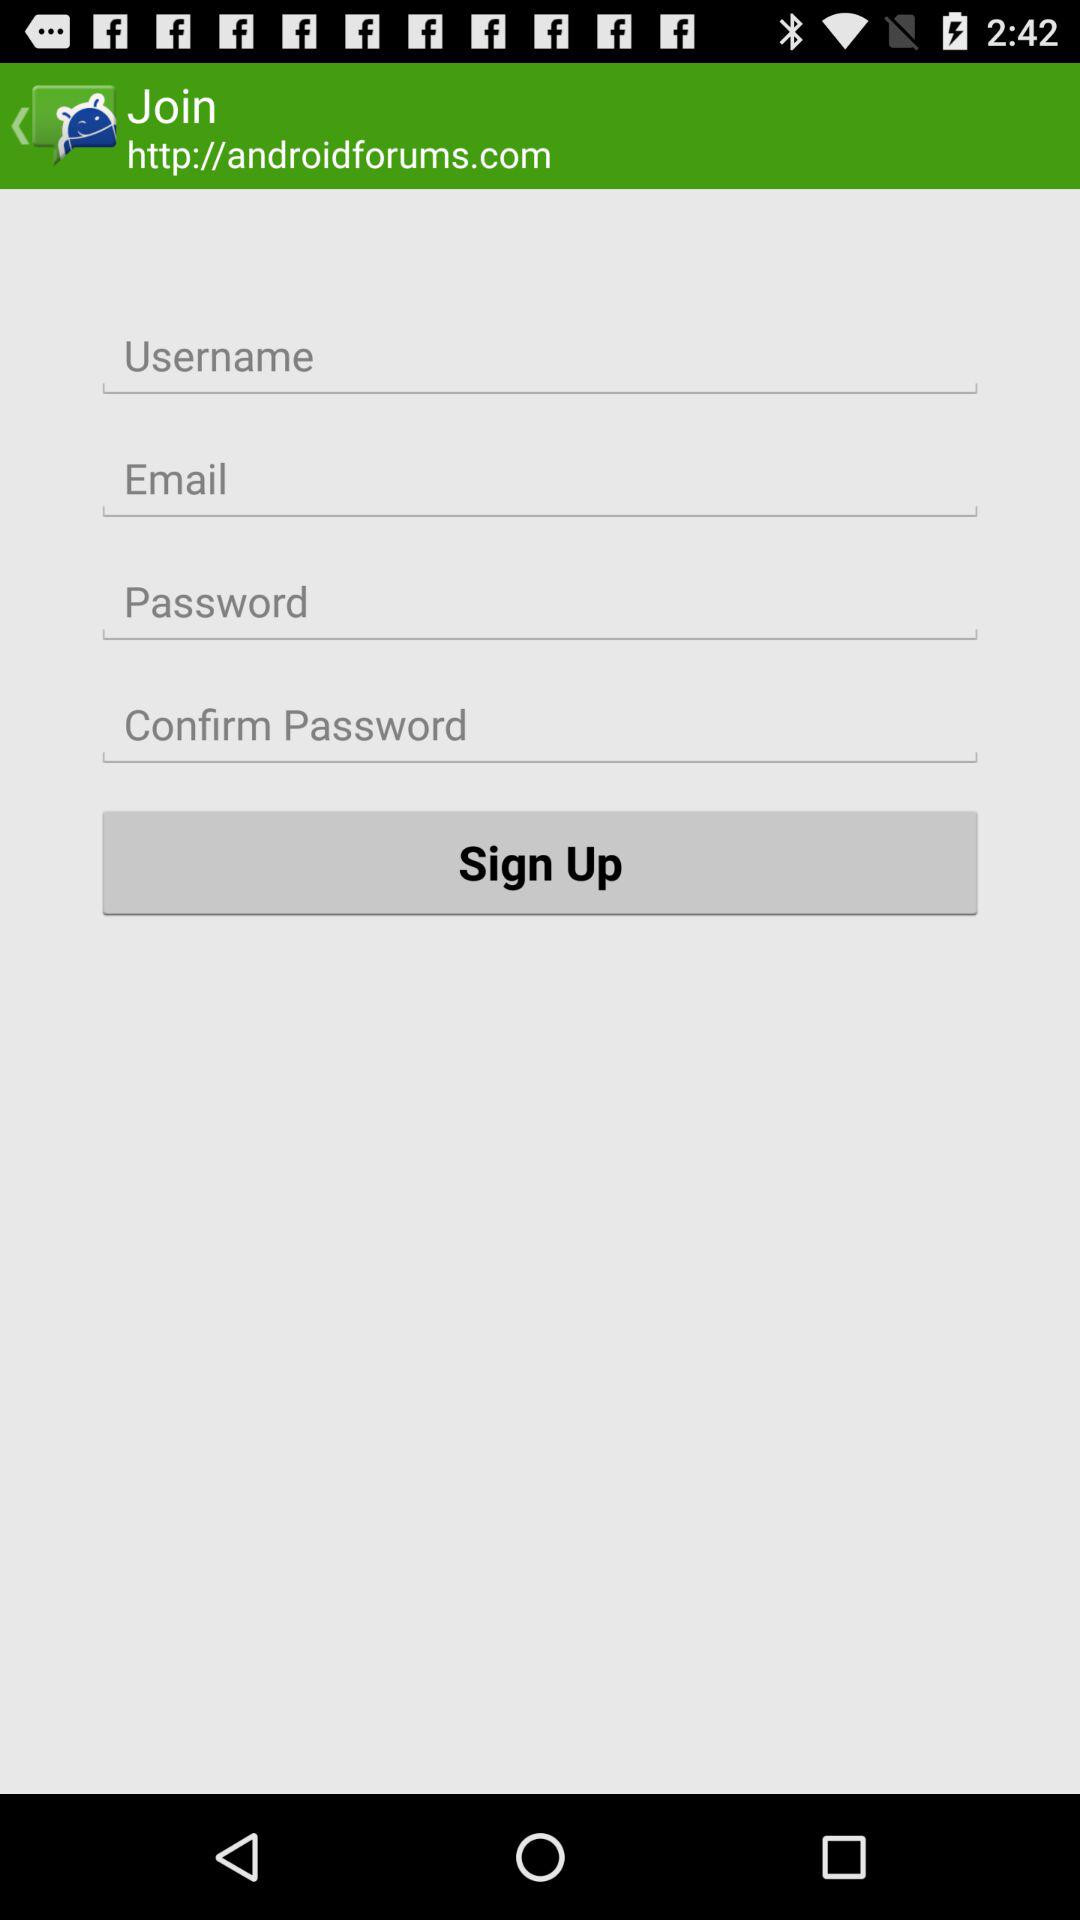How many text inputs are required to sign up?
Answer the question using a single word or phrase. 4 